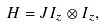Convert formula to latex. <formula><loc_0><loc_0><loc_500><loc_500>H = J I _ { z } \otimes I _ { z } ,</formula> 